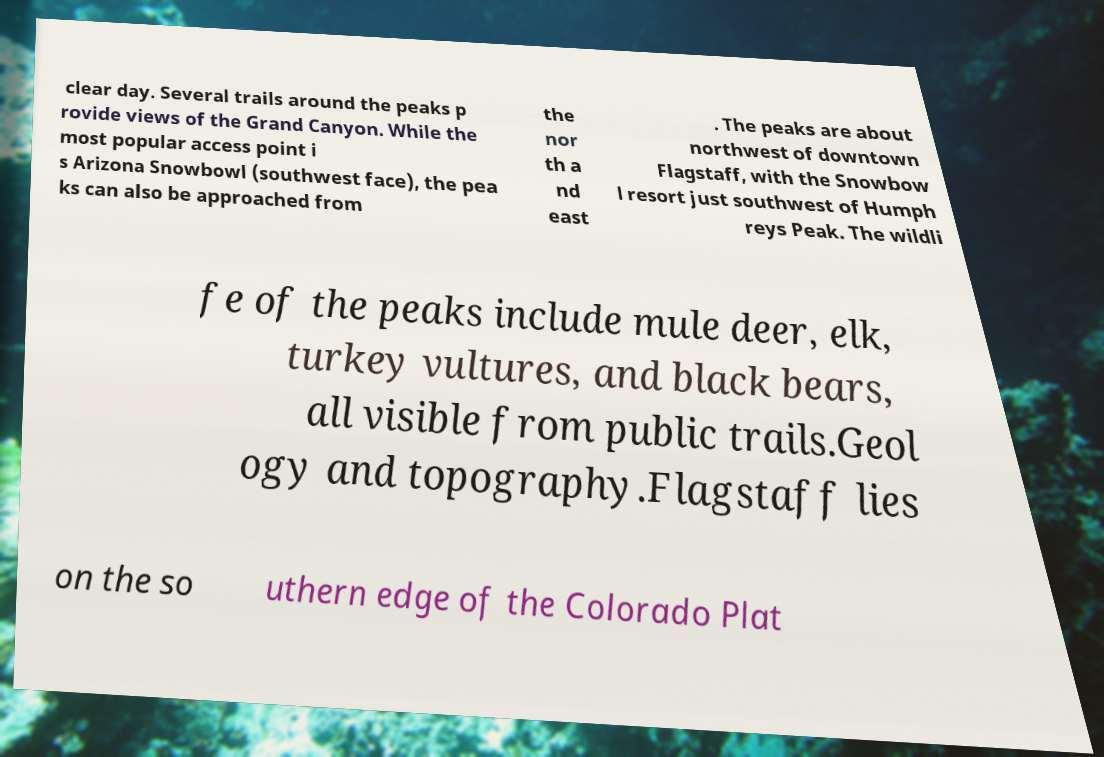What messages or text are displayed in this image? I need them in a readable, typed format. clear day. Several trails around the peaks p rovide views of the Grand Canyon. While the most popular access point i s Arizona Snowbowl (southwest face), the pea ks can also be approached from the nor th a nd east . The peaks are about northwest of downtown Flagstaff, with the Snowbow l resort just southwest of Humph reys Peak. The wildli fe of the peaks include mule deer, elk, turkey vultures, and black bears, all visible from public trails.Geol ogy and topography.Flagstaff lies on the so uthern edge of the Colorado Plat 